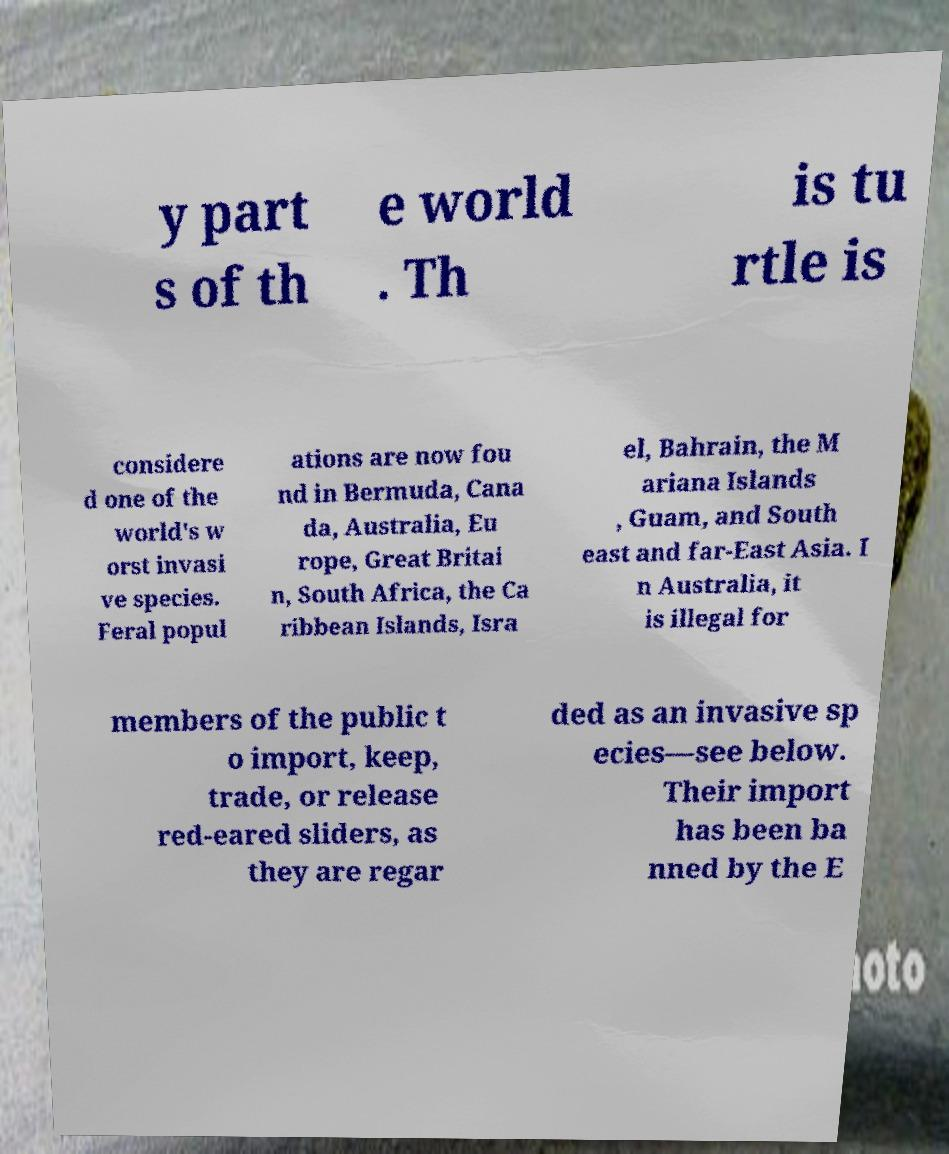Can you read and provide the text displayed in the image?This photo seems to have some interesting text. Can you extract and type it out for me? y part s of th e world . Th is tu rtle is considere d one of the world's w orst invasi ve species. Feral popul ations are now fou nd in Bermuda, Cana da, Australia, Eu rope, Great Britai n, South Africa, the Ca ribbean Islands, Isra el, Bahrain, the M ariana Islands , Guam, and South east and far-East Asia. I n Australia, it is illegal for members of the public t o import, keep, trade, or release red-eared sliders, as they are regar ded as an invasive sp ecies—see below. Their import has been ba nned by the E 